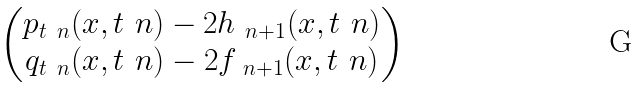Convert formula to latex. <formula><loc_0><loc_0><loc_500><loc_500>\begin{pmatrix} p _ { t _ { \ } n } ( x , t _ { \ } n ) - 2 h _ { \ n + 1 } ( x , t _ { \ } n ) \\ q _ { t _ { \ } n } ( x , t _ { \ } n ) - 2 f _ { \ n + 1 } ( x , t _ { \ } n ) \end{pmatrix}</formula> 